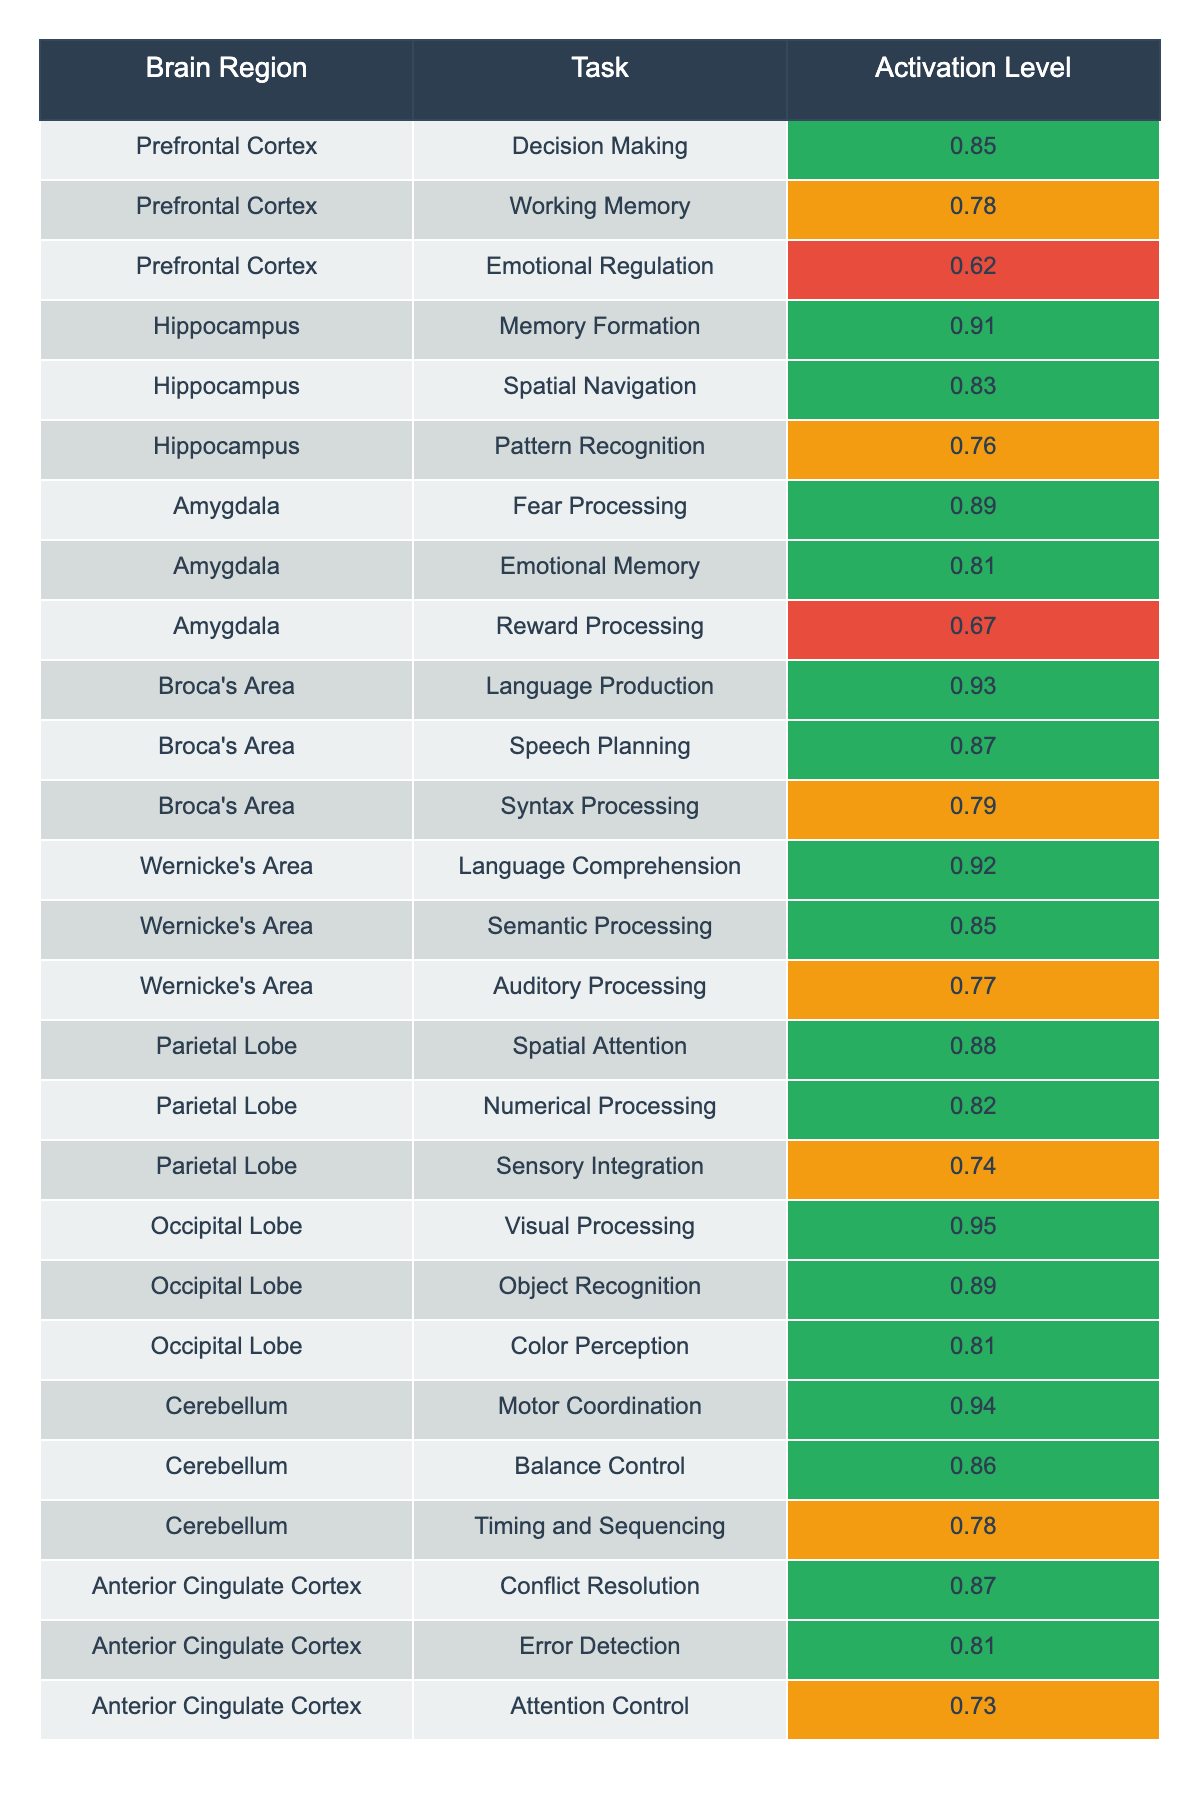What is the activation level of the Prefrontal Cortex during Emotional Regulation? The table shows that the activation level for the Prefrontal Cortex during Emotional Regulation is listed as 0.62.
Answer: 0.62 Which brain region has the highest activation level during language production? From the table, Broca's Area has the highest activation level during Language Production at 0.93.
Answer: 0.93 What are the activation levels for the Hippocampus while performing Spatial Navigation and Pattern Recognition? The table presents the activation levels for the Hippocampus as 0.83 for Spatial Navigation and 0.76 for Pattern Recognition.
Answer: 0.83 and 0.76 Is the activation level of the Amygdala higher during Fear Processing or Reward Processing? Fear Processing has an activation level of 0.89 while Reward Processing has a lower level at 0.67, indicating Fear Processing is higher.
Answer: Yes What is the average activation level for the Wernicke's Area tasks? The activation levels for Wernicke's Area are 0.92 for Language Comprehension, 0.85 for Semantic Processing, and 0.77 for Auditory Processing. The average is (0.92 + 0.85 + 0.77) / 3 = 0.818.
Answer: 0.818 How does the activation level of the Cerebellum during Timing and Sequencing compare to that during Balance Control? The activation level for Timing and Sequencing is 0.78, while for Balance Control it is higher at 0.86, meaning Balance Control has a greater activation level.
Answer: Higher during Balance Control Which brain region has the lowest activation level for a specific task and what is that level? The table shows that the Anterior Cingulate Cortex has the lowest activation level of 0.73 during Attention Control, which is the lowest across all tasks.
Answer: 0.73 What is the total activation level of the Prefrontal Cortex for its tasks? The activation levels for the Prefrontal Cortex are 0.85 for Decision Making, 0.78 for Working Memory, and 0.62 for Emotional Regulation. Summing these levels gives 0.85 + 0.78 + 0.62 = 2.25.
Answer: 2.25 Which task associated with the Occipital Lobe has the lowest activation level? The activation levels for the Occipital Lobe tasks are 0.95 for Visual Processing, 0.89 for Object Recognition, and 0.81 for Color Perception. The lowest is 0.81 for Color Perception.
Answer: 0.81 Determine whether the Hippocampus has a higher activation level for Memory Formation than the Parietal Lobe for Spatial Attention. The Hippocampus has an activation level of 0.91 for Memory Formation, while the Parietal Lobe has 0.88 for Spatial Attention. Since 0.91 is greater than 0.88, the Hippocampus does indeed have a higher level.
Answer: Yes 